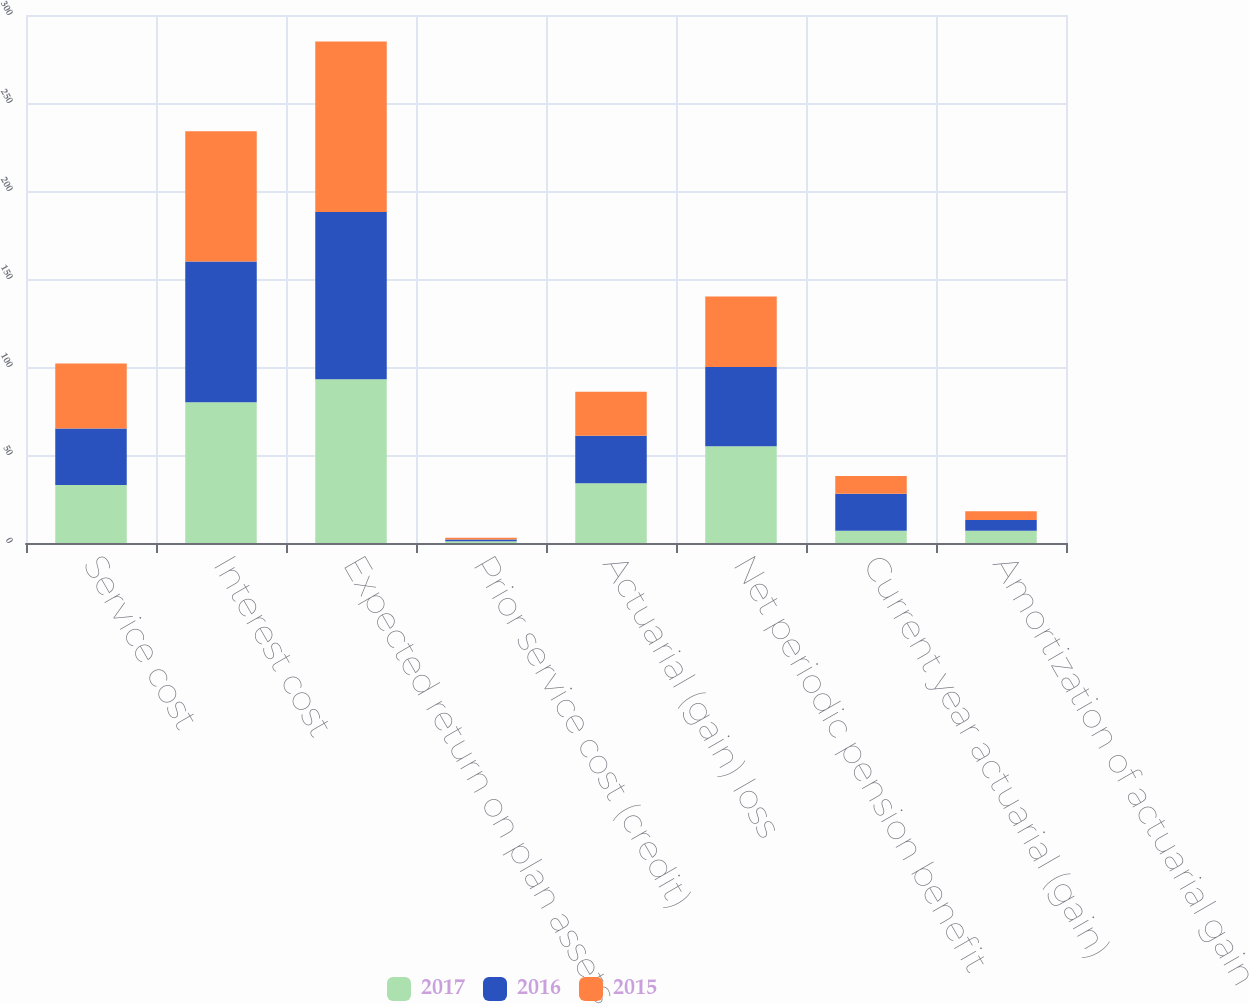Convert chart to OTSL. <chart><loc_0><loc_0><loc_500><loc_500><stacked_bar_chart><ecel><fcel>Service cost<fcel>Interest cost<fcel>Expected return on plan assets<fcel>Prior service cost (credit)<fcel>Actuarial (gain) loss<fcel>Net periodic pension benefit<fcel>Current year actuarial (gain)<fcel>Amortization of actuarial gain<nl><fcel>2017<fcel>33<fcel>80<fcel>93<fcel>1<fcel>34<fcel>55<fcel>7<fcel>7<nl><fcel>2016<fcel>32<fcel>80<fcel>95<fcel>1<fcel>27<fcel>45<fcel>21<fcel>6<nl><fcel>2015<fcel>37<fcel>74<fcel>97<fcel>1<fcel>25<fcel>40<fcel>10<fcel>5<nl></chart> 